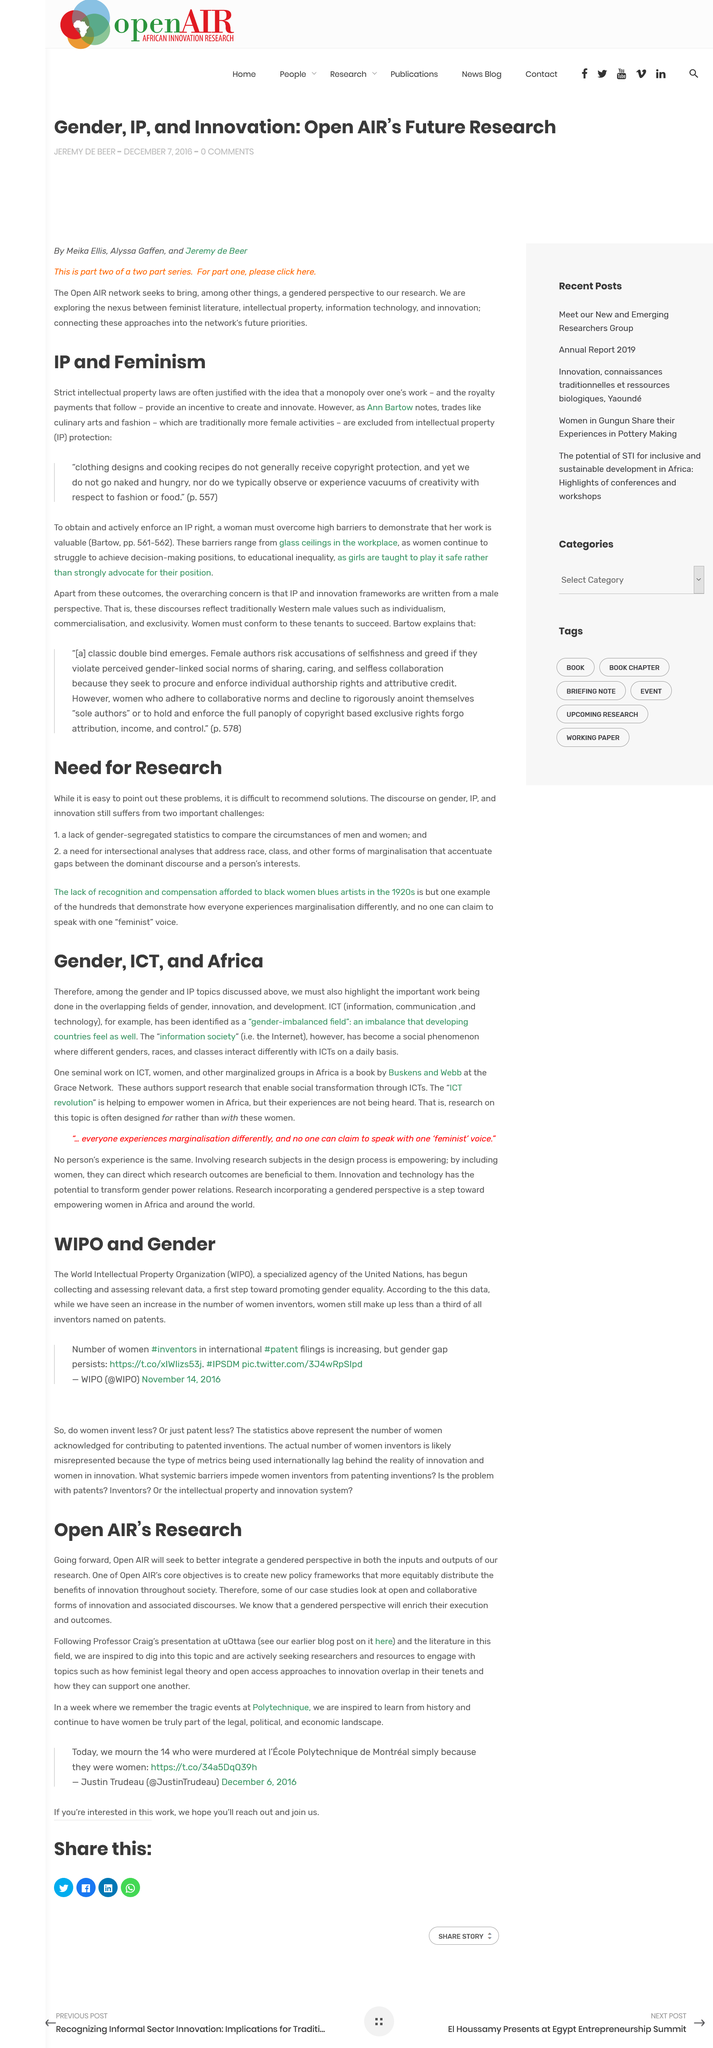Indicate a few pertinent items in this graphic. Going forward, Open Air will prioritize incorporating a gender-based perspective into both its research inputs and outputs. Professor Craig held his presentation at uOttawa. The World Intellectual Property Organization, commonly referred to as WIPO, is an international organization dedicated to the protection and promotion of intellectual property rights. The continent mentioned in the text is Africa. Women make up less than a third of all inventors named on patents, according to a recent study. 